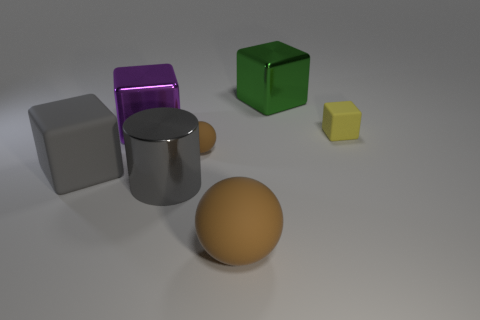Are there more big metal cubes to the right of the big purple cube than purple objects on the right side of the large green shiny thing? Upon reviewing the image, it appears that there is one large metal cube to the right of the big purple cube, whereas there are no purple objects to the right of the large green shiny object. Therefore, the comparison suggests that the number of big metal cubes to the right of the big purple cube and purple objects on the right side of the large green shiny thing are not the same, as there are more big metal cubes in the context of the question. It would be more accurate to say, 'There is one big metal cube to the right of the big purple cube, which is a greater number than the zero purple objects found on the right side of the large green shiny thing.' 